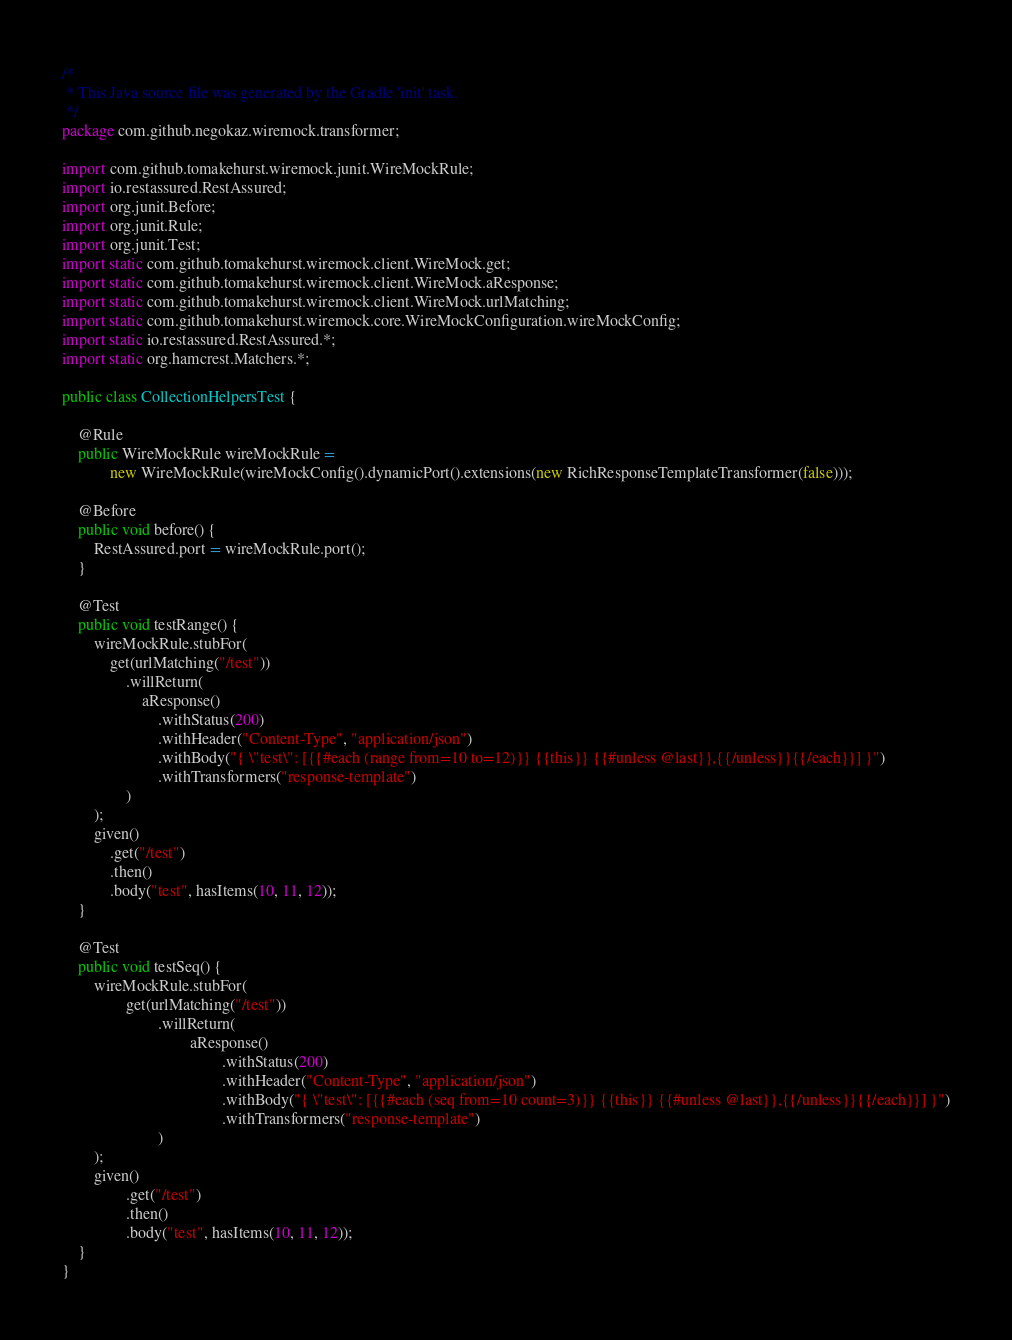<code> <loc_0><loc_0><loc_500><loc_500><_Java_>/*
 * This Java source file was generated by the Gradle 'init' task.
 */
package com.github.negokaz.wiremock.transformer;

import com.github.tomakehurst.wiremock.junit.WireMockRule;
import io.restassured.RestAssured;
import org.junit.Before;
import org.junit.Rule;
import org.junit.Test;
import static com.github.tomakehurst.wiremock.client.WireMock.get;
import static com.github.tomakehurst.wiremock.client.WireMock.aResponse;
import static com.github.tomakehurst.wiremock.client.WireMock.urlMatching;
import static com.github.tomakehurst.wiremock.core.WireMockConfiguration.wireMockConfig;
import static io.restassured.RestAssured.*;
import static org.hamcrest.Matchers.*;

public class CollectionHelpersTest {

    @Rule
    public WireMockRule wireMockRule =
            new WireMockRule(wireMockConfig().dynamicPort().extensions(new RichResponseTemplateTransformer(false)));

    @Before
    public void before() {
        RestAssured.port = wireMockRule.port();
    }

    @Test
    public void testRange() {
        wireMockRule.stubFor(
            get(urlMatching("/test"))
                .willReturn(
                    aResponse()
                        .withStatus(200)
                        .withHeader("Content-Type", "application/json")
                        .withBody("{ \"test\": [{{#each (range from=10 to=12)}} {{this}} {{#unless @last}},{{/unless}}{{/each}}] }")
                        .withTransformers("response-template")
                )
        );
        given()
            .get("/test")
            .then()
            .body("test", hasItems(10, 11, 12));
    }

    @Test
    public void testSeq() {
        wireMockRule.stubFor(
                get(urlMatching("/test"))
                        .willReturn(
                                aResponse()
                                        .withStatus(200)
                                        .withHeader("Content-Type", "application/json")
                                        .withBody("{ \"test\": [{{#each (seq from=10 count=3)}} {{this}} {{#unless @last}},{{/unless}}{{/each}}] }")
                                        .withTransformers("response-template")
                        )
        );
        given()
                .get("/test")
                .then()
                .body("test", hasItems(10, 11, 12));
    }
}
</code> 